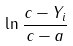Convert formula to latex. <formula><loc_0><loc_0><loc_500><loc_500>\ln { \frac { c - Y _ { i } } { c - a } }</formula> 